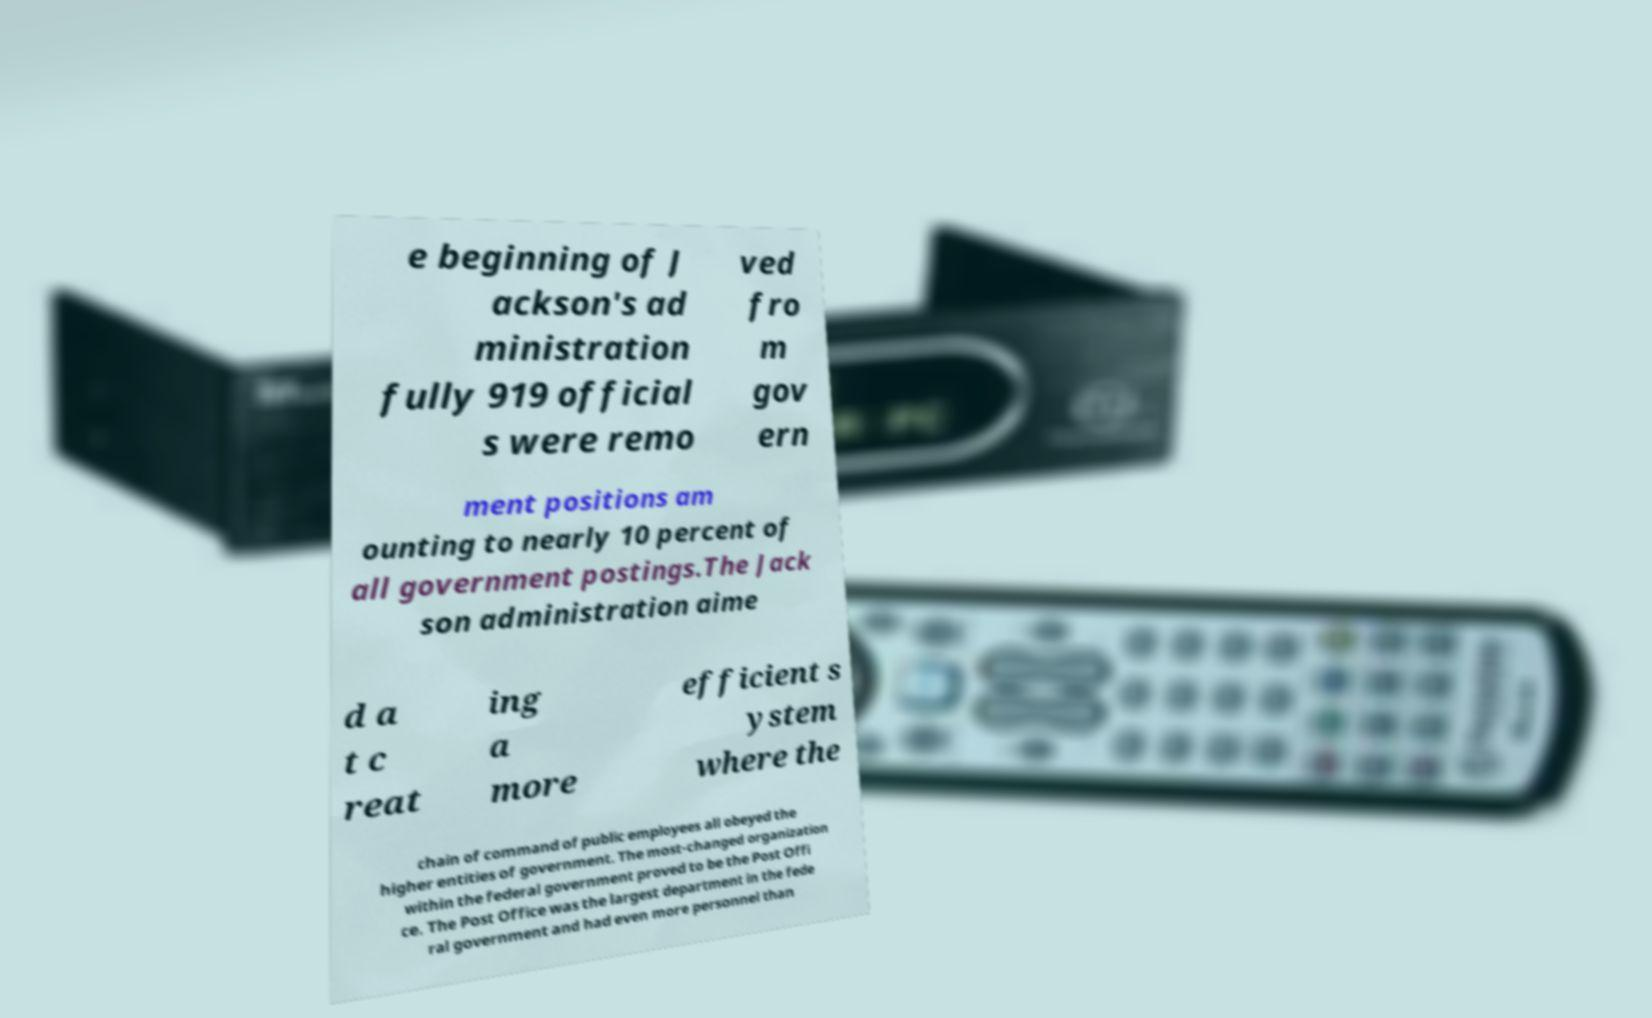Can you read and provide the text displayed in the image?This photo seems to have some interesting text. Can you extract and type it out for me? e beginning of J ackson's ad ministration fully 919 official s were remo ved fro m gov ern ment positions am ounting to nearly 10 percent of all government postings.The Jack son administration aime d a t c reat ing a more efficient s ystem where the chain of command of public employees all obeyed the higher entities of government. The most-changed organization within the federal government proved to be the Post Offi ce. The Post Office was the largest department in the fede ral government and had even more personnel than 